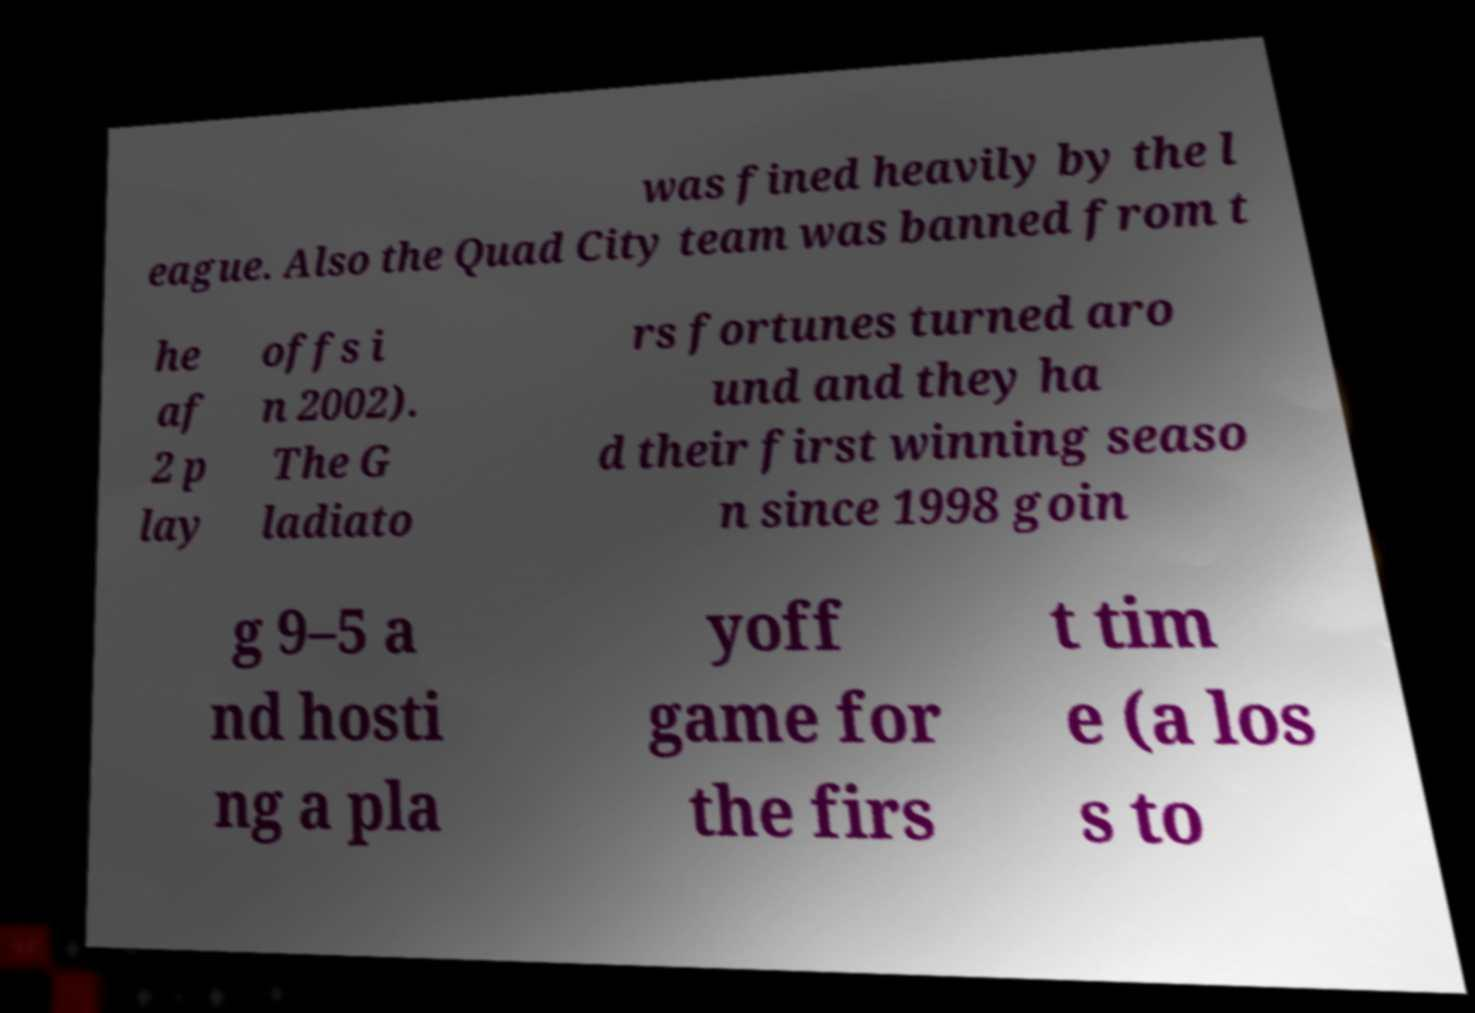Please read and relay the text visible in this image. What does it say? was fined heavily by the l eague. Also the Quad City team was banned from t he af 2 p lay offs i n 2002). The G ladiato rs fortunes turned aro und and they ha d their first winning seaso n since 1998 goin g 9–5 a nd hosti ng a pla yoff game for the firs t tim e (a los s to 